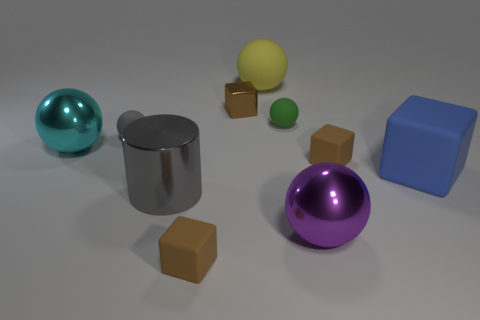What is the large blue block made of?
Your answer should be very brief. Rubber. Is the color of the large matte object that is in front of the gray sphere the same as the small metal cube?
Your response must be concise. No. Are there any other things that are the same shape as the large gray metal thing?
Your answer should be compact. No. What is the color of the big rubber object that is the same shape as the tiny gray matte object?
Your response must be concise. Yellow. There is a tiny ball that is behind the small gray object; what material is it?
Offer a very short reply. Rubber. The tiny metal object has what color?
Make the answer very short. Brown. There is a brown rubber thing left of the purple thing; does it have the same size as the big rubber block?
Your response must be concise. No. What material is the sphere that is to the right of the small matte sphere that is right of the tiny matte cube to the left of the yellow thing?
Provide a short and direct response. Metal. Do the metallic object in front of the gray metallic cylinder and the metal thing that is left of the gray metal thing have the same color?
Your answer should be compact. No. There is a gray thing on the left side of the metal cylinder that is in front of the big blue cube; what is its material?
Offer a terse response. Rubber. 